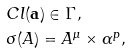<formula> <loc_0><loc_0><loc_500><loc_500>& C l ( \mathbf a ) \in \Gamma , \\ & \sigma ( A ) = A ^ { \mu } \times \alpha ^ { p } , \\</formula> 